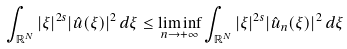<formula> <loc_0><loc_0><loc_500><loc_500>\int _ { \mathbb { R } ^ { N } } | \xi | ^ { 2 s } | \hat { u } ( \xi ) | ^ { 2 } \, d \xi \leq \liminf _ { n \to + \infty } \int _ { \mathbb { R } ^ { N } } | \xi | ^ { 2 s } | \hat { u } _ { n } ( \xi ) | ^ { 2 } \, d \xi</formula> 